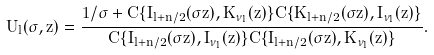<formula> <loc_0><loc_0><loc_500><loc_500>U _ { l } ( \sigma , z ) = \frac { 1 / \sigma + C \{ I _ { l + n / 2 } ( \sigma z ) , K _ { \nu _ { l } } ( z ) \} C \{ K _ { l + n / 2 } ( \sigma z ) , I _ { \nu _ { l } } ( z ) \} } { C \{ I _ { l + n / 2 } ( \sigma z ) , I _ { \nu _ { l } } ( z ) \} C \{ I _ { l + n / 2 } ( \sigma z ) , K _ { \nu _ { l } } ( z ) \} } .</formula> 